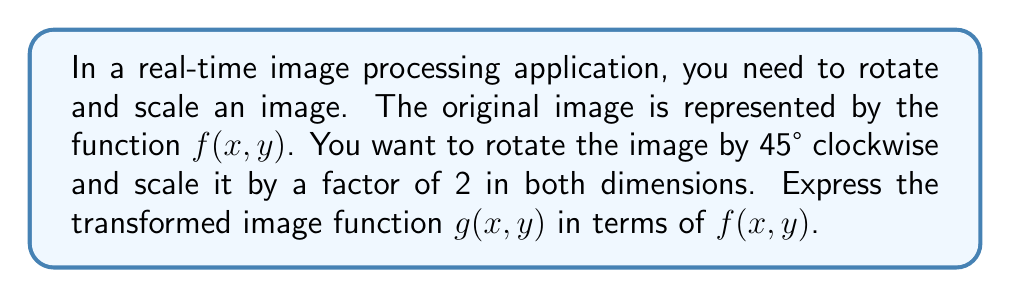Could you help me with this problem? To solve this problem, we'll follow these steps:

1) First, let's consider the rotation. A 45° clockwise rotation can be represented by the transformation:
   $$x' = x\cos(45°) + y\sin(45°)$$
   $$y' = -x\sin(45°) + y\cos(45°)$$

2) We know that $\cos(45°) = \sin(45°) = \frac{1}{\sqrt{2}}$, so we can simplify:
   $$x' = \frac{x}{\sqrt{2}} + \frac{y}{\sqrt{2}} = \frac{x+y}{\sqrt{2}}$$
   $$y' = -\frac{x}{\sqrt{2}} + \frac{y}{\sqrt{2}} = \frac{-x+y}{\sqrt{2}}$$

3) Now, let's consider the scaling. Scaling by a factor of 2 means we need to divide our coordinates by 2:
   $$x'' = \frac{x'}{2} = \frac{x+y}{2\sqrt{2}}$$
   $$y'' = \frac{y'}{2} = \frac{-x+y}{2\sqrt{2}}$$

4) The transformed function $g(x,y)$ will be equal to $f(x'',y'')$. Therefore:
   $$g(x,y) = f\left(\frac{x+y}{2\sqrt{2}}, \frac{-x+y}{2\sqrt{2}}\right)$$

This expression represents the original image rotated 45° clockwise and scaled by a factor of 2 in both dimensions.
Answer: $g(x,y) = f\left(\frac{x+y}{2\sqrt{2}}, \frac{-x+y}{2\sqrt{2}}\right)$ 